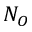Convert formula to latex. <formula><loc_0><loc_0><loc_500><loc_500>N _ { O }</formula> 